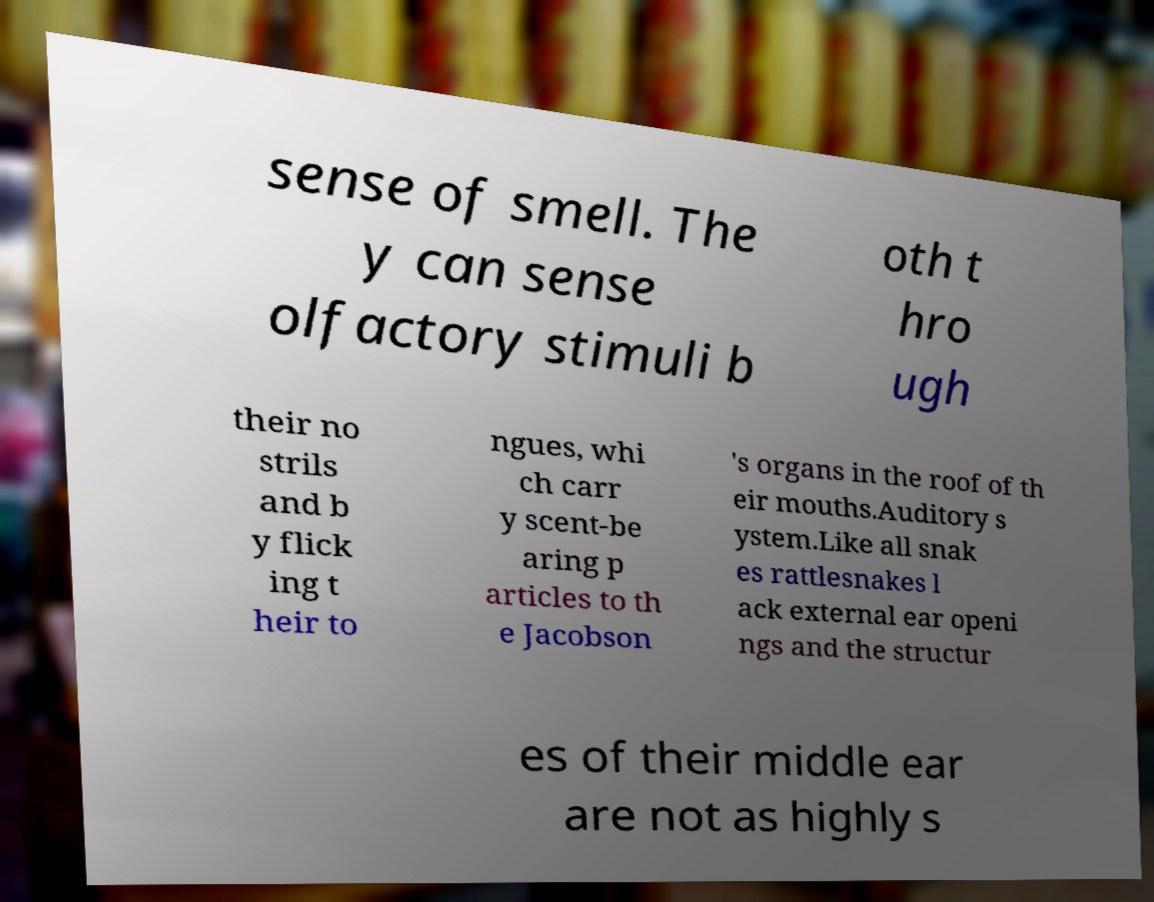Could you extract and type out the text from this image? sense of smell. The y can sense olfactory stimuli b oth t hro ugh their no strils and b y flick ing t heir to ngues, whi ch carr y scent-be aring p articles to th e Jacobson 's organs in the roof of th eir mouths.Auditory s ystem.Like all snak es rattlesnakes l ack external ear openi ngs and the structur es of their middle ear are not as highly s 